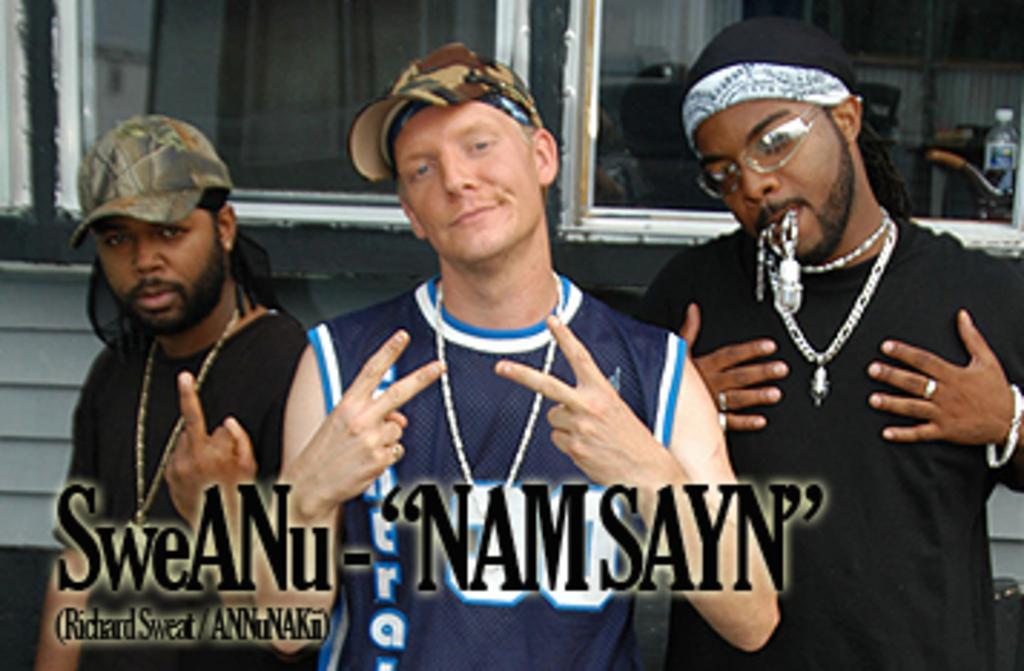Please provide a concise description of this image. In the night I can see three men are standing. These men are wearing caps, neck chains and some other objects. I can also see a watermark on the image. In the background I can see a bottle, windows and some other objects. 